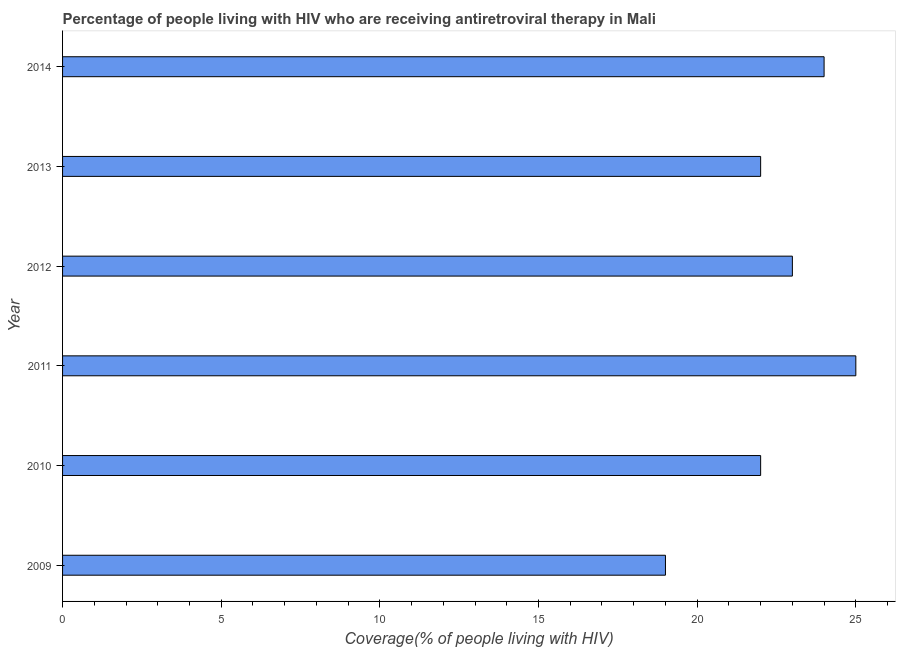Does the graph contain grids?
Provide a succinct answer. No. What is the title of the graph?
Offer a terse response. Percentage of people living with HIV who are receiving antiretroviral therapy in Mali. What is the label or title of the X-axis?
Provide a short and direct response. Coverage(% of people living with HIV). What is the label or title of the Y-axis?
Your response must be concise. Year. What is the antiretroviral therapy coverage in 2009?
Provide a succinct answer. 19. Across all years, what is the maximum antiretroviral therapy coverage?
Offer a terse response. 25. In which year was the antiretroviral therapy coverage maximum?
Offer a very short reply. 2011. What is the sum of the antiretroviral therapy coverage?
Provide a short and direct response. 135. What is the difference between the antiretroviral therapy coverage in 2011 and 2014?
Ensure brevity in your answer.  1. Do a majority of the years between 2010 and 2013 (inclusive) have antiretroviral therapy coverage greater than 8 %?
Your answer should be very brief. Yes. What is the ratio of the antiretroviral therapy coverage in 2011 to that in 2014?
Offer a very short reply. 1.04. Is the antiretroviral therapy coverage in 2012 less than that in 2013?
Give a very brief answer. No. What is the difference between the highest and the second highest antiretroviral therapy coverage?
Provide a succinct answer. 1. What is the difference between the highest and the lowest antiretroviral therapy coverage?
Give a very brief answer. 6. How many bars are there?
Provide a short and direct response. 6. Are all the bars in the graph horizontal?
Offer a very short reply. Yes. How many years are there in the graph?
Provide a succinct answer. 6. What is the difference between two consecutive major ticks on the X-axis?
Your response must be concise. 5. What is the Coverage(% of people living with HIV) of 2012?
Your answer should be compact. 23. What is the Coverage(% of people living with HIV) of 2014?
Offer a very short reply. 24. What is the difference between the Coverage(% of people living with HIV) in 2009 and 2010?
Give a very brief answer. -3. What is the difference between the Coverage(% of people living with HIV) in 2009 and 2011?
Offer a very short reply. -6. What is the difference between the Coverage(% of people living with HIV) in 2009 and 2014?
Offer a very short reply. -5. What is the difference between the Coverage(% of people living with HIV) in 2010 and 2011?
Provide a short and direct response. -3. What is the difference between the Coverage(% of people living with HIV) in 2010 and 2014?
Your answer should be compact. -2. What is the difference between the Coverage(% of people living with HIV) in 2011 and 2013?
Offer a terse response. 3. What is the difference between the Coverage(% of people living with HIV) in 2012 and 2013?
Your answer should be very brief. 1. What is the difference between the Coverage(% of people living with HIV) in 2013 and 2014?
Make the answer very short. -2. What is the ratio of the Coverage(% of people living with HIV) in 2009 to that in 2010?
Provide a succinct answer. 0.86. What is the ratio of the Coverage(% of people living with HIV) in 2009 to that in 2011?
Your answer should be very brief. 0.76. What is the ratio of the Coverage(% of people living with HIV) in 2009 to that in 2012?
Ensure brevity in your answer.  0.83. What is the ratio of the Coverage(% of people living with HIV) in 2009 to that in 2013?
Offer a very short reply. 0.86. What is the ratio of the Coverage(% of people living with HIV) in 2009 to that in 2014?
Offer a very short reply. 0.79. What is the ratio of the Coverage(% of people living with HIV) in 2010 to that in 2011?
Ensure brevity in your answer.  0.88. What is the ratio of the Coverage(% of people living with HIV) in 2010 to that in 2012?
Offer a terse response. 0.96. What is the ratio of the Coverage(% of people living with HIV) in 2010 to that in 2013?
Your response must be concise. 1. What is the ratio of the Coverage(% of people living with HIV) in 2010 to that in 2014?
Your answer should be compact. 0.92. What is the ratio of the Coverage(% of people living with HIV) in 2011 to that in 2012?
Your response must be concise. 1.09. What is the ratio of the Coverage(% of people living with HIV) in 2011 to that in 2013?
Your response must be concise. 1.14. What is the ratio of the Coverage(% of people living with HIV) in 2011 to that in 2014?
Give a very brief answer. 1.04. What is the ratio of the Coverage(% of people living with HIV) in 2012 to that in 2013?
Offer a very short reply. 1.04. What is the ratio of the Coverage(% of people living with HIV) in 2012 to that in 2014?
Offer a very short reply. 0.96. What is the ratio of the Coverage(% of people living with HIV) in 2013 to that in 2014?
Make the answer very short. 0.92. 